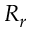Convert formula to latex. <formula><loc_0><loc_0><loc_500><loc_500>R _ { r }</formula> 